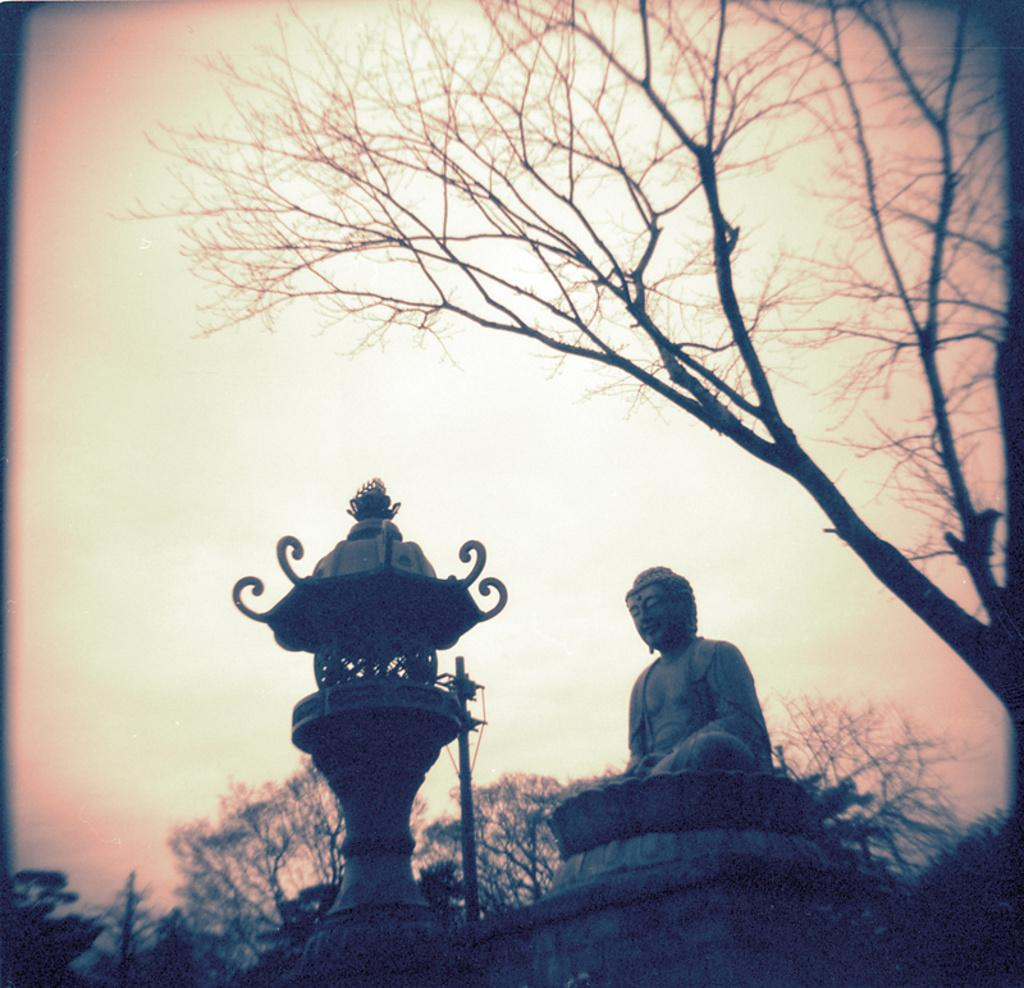What is the main subject in the image? There is a sculpture in the image. What material is the metal object made of? The metal object in the image is made of metal. What type of vegetation is present in the image? There are trees in the image. What is visible in the background of the image? The sky is visible in the image. What type of cheese can be seen being balanced on the nerve of the sculpture in the image? There is no cheese or nerve present in the image; it features a sculpture and a metal object. 